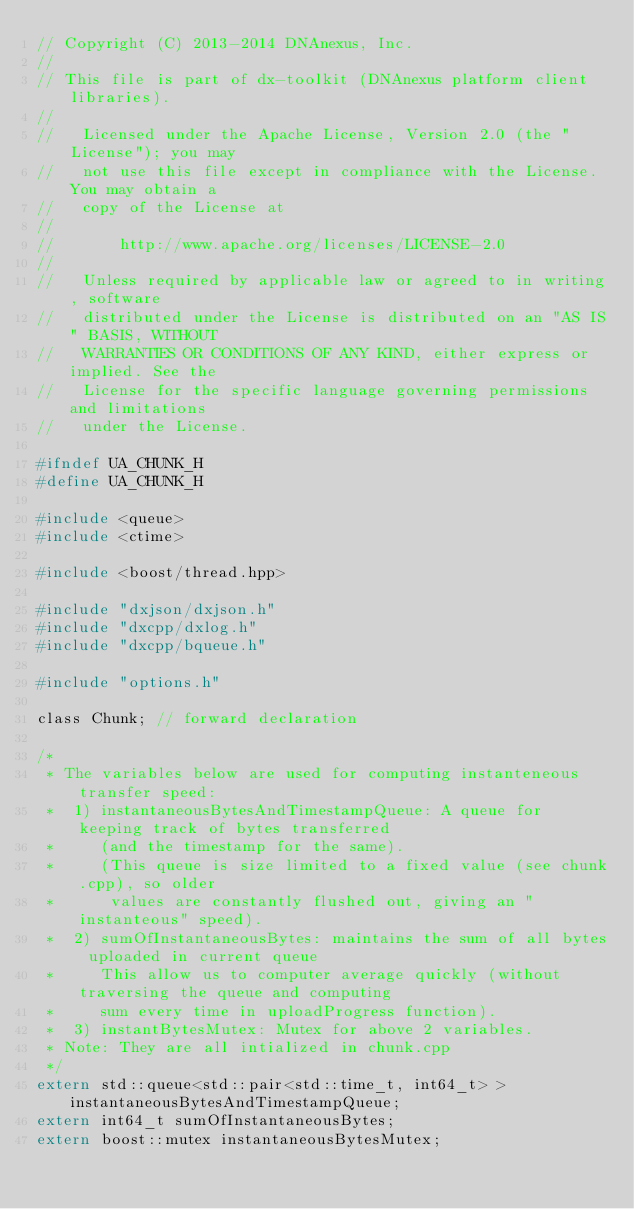Convert code to text. <code><loc_0><loc_0><loc_500><loc_500><_C_>// Copyright (C) 2013-2014 DNAnexus, Inc.
//
// This file is part of dx-toolkit (DNAnexus platform client libraries).
//
//   Licensed under the Apache License, Version 2.0 (the "License"); you may
//   not use this file except in compliance with the License. You may obtain a
//   copy of the License at
//
//       http://www.apache.org/licenses/LICENSE-2.0
//
//   Unless required by applicable law or agreed to in writing, software
//   distributed under the License is distributed on an "AS IS" BASIS, WITHOUT
//   WARRANTIES OR CONDITIONS OF ANY KIND, either express or implied. See the
//   License for the specific language governing permissions and limitations
//   under the License.

#ifndef UA_CHUNK_H
#define UA_CHUNK_H

#include <queue>
#include <ctime>

#include <boost/thread.hpp>

#include "dxjson/dxjson.h"
#include "dxcpp/dxlog.h"
#include "dxcpp/bqueue.h"

#include "options.h"

class Chunk; // forward declaration

/*
 * The variables below are used for computing instanteneous transfer speed: 
 *  1) instantaneousBytesAndTimestampQueue: A queue for keeping track of bytes transferred
 *     (and the timestamp for the same).
 *     (This queue is size limited to a fixed value (see chunk.cpp), so older
 *      values are constantly flushed out, giving an "instanteous" speed).
 *  2) sumOfInstantaneousBytes: maintains the sum of all bytes uploaded in current queue
 *     This allow us to computer average quickly (without traversing the queue and computing
 *     sum every time in uploadProgress function).
 *  3) instantBytesMutex: Mutex for above 2 variables.
 * Note: They are all intialized in chunk.cpp
 */
extern std::queue<std::pair<std::time_t, int64_t> > instantaneousBytesAndTimestampQueue;
extern int64_t sumOfInstantaneousBytes;
extern boost::mutex instantaneousBytesMutex;
</code> 